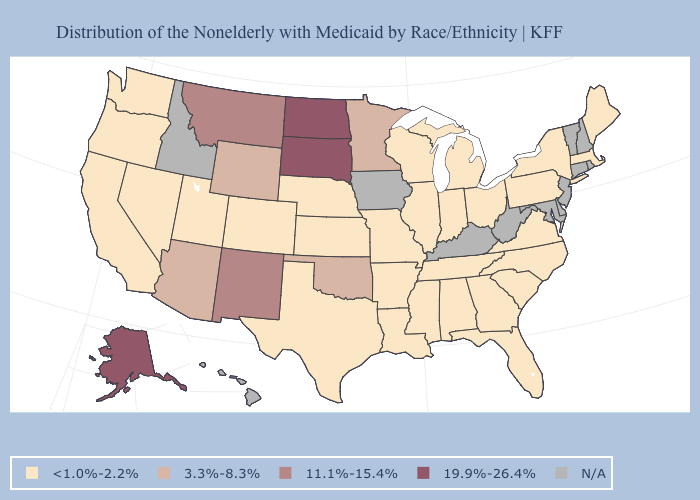Is the legend a continuous bar?
Short answer required. No. What is the value of Virginia?
Answer briefly. <1.0%-2.2%. Does Tennessee have the lowest value in the USA?
Concise answer only. Yes. Is the legend a continuous bar?
Quick response, please. No. Which states have the highest value in the USA?
Short answer required. Alaska, North Dakota, South Dakota. Which states have the highest value in the USA?
Write a very short answer. Alaska, North Dakota, South Dakota. Name the states that have a value in the range 19.9%-26.4%?
Write a very short answer. Alaska, North Dakota, South Dakota. Name the states that have a value in the range 11.1%-15.4%?
Keep it brief. Montana, New Mexico. Does the map have missing data?
Be succinct. Yes. Name the states that have a value in the range <1.0%-2.2%?
Short answer required. Alabama, Arkansas, California, Colorado, Florida, Georgia, Illinois, Indiana, Kansas, Louisiana, Maine, Massachusetts, Michigan, Mississippi, Missouri, Nebraska, Nevada, New York, North Carolina, Ohio, Oregon, Pennsylvania, South Carolina, Tennessee, Texas, Utah, Virginia, Washington, Wisconsin. Among the states that border Nebraska , which have the lowest value?
Concise answer only. Colorado, Kansas, Missouri. Does Indiana have the lowest value in the USA?
Quick response, please. Yes. Name the states that have a value in the range N/A?
Give a very brief answer. Connecticut, Delaware, Hawaii, Idaho, Iowa, Kentucky, Maryland, New Hampshire, New Jersey, Rhode Island, Vermont, West Virginia. Name the states that have a value in the range N/A?
Short answer required. Connecticut, Delaware, Hawaii, Idaho, Iowa, Kentucky, Maryland, New Hampshire, New Jersey, Rhode Island, Vermont, West Virginia. 